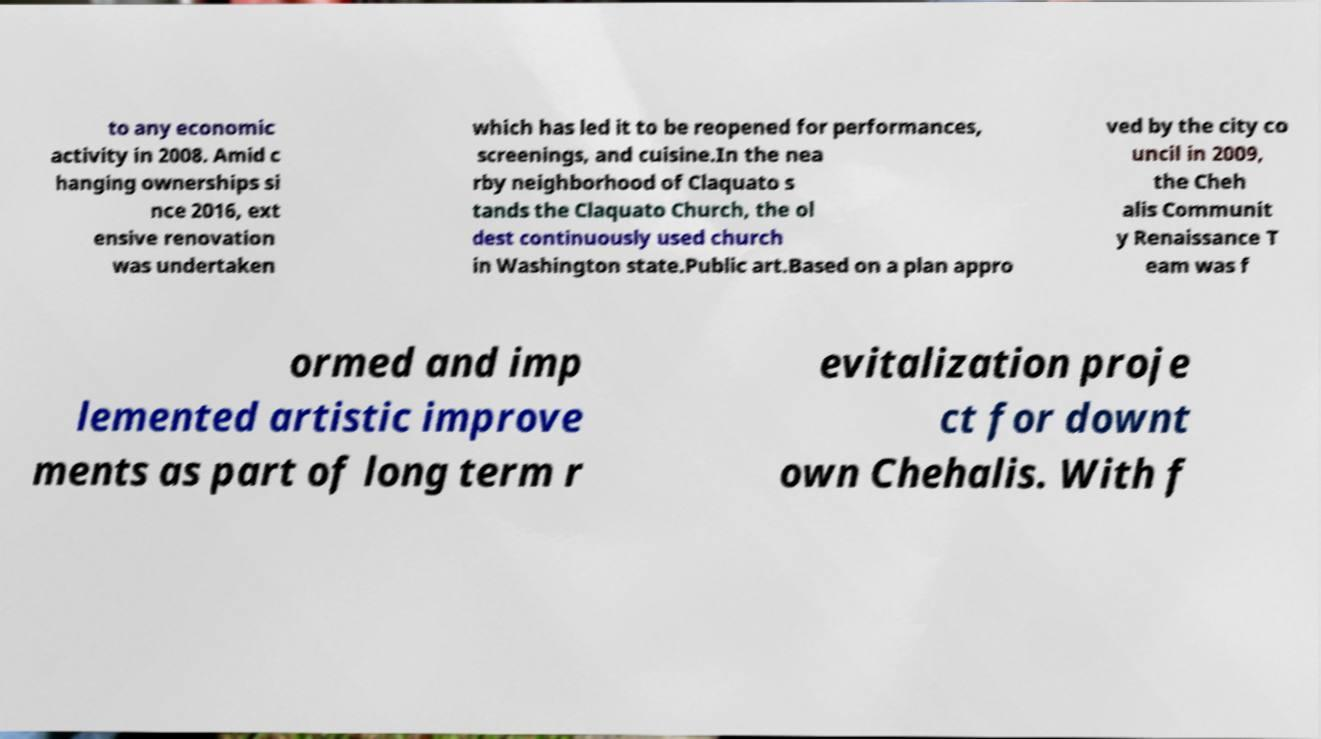What messages or text are displayed in this image? I need them in a readable, typed format. to any economic activity in 2008. Amid c hanging ownerships si nce 2016, ext ensive renovation was undertaken which has led it to be reopened for performances, screenings, and cuisine.In the nea rby neighborhood of Claquato s tands the Claquato Church, the ol dest continuously used church in Washington state.Public art.Based on a plan appro ved by the city co uncil in 2009, the Cheh alis Communit y Renaissance T eam was f ormed and imp lemented artistic improve ments as part of long term r evitalization proje ct for downt own Chehalis. With f 